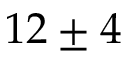<formula> <loc_0><loc_0><loc_500><loc_500>1 2 \pm 4</formula> 